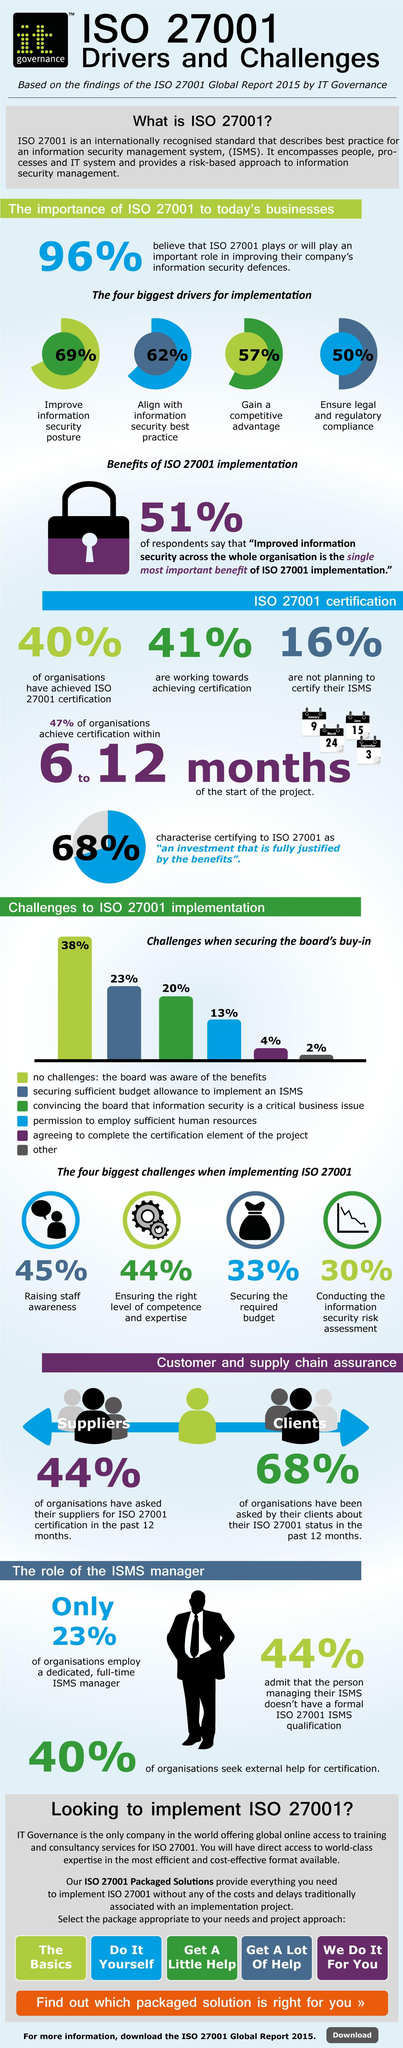Draw attention to some important aspects in this diagram. A significant percentage of organizations, 41%, are actively working towards achieving certification. In the survey of 100 organizations, 60% did not seek external help for certification. According to the survey results, 77% of organizations did not employ a dedicated, full-time ISMS manager. 